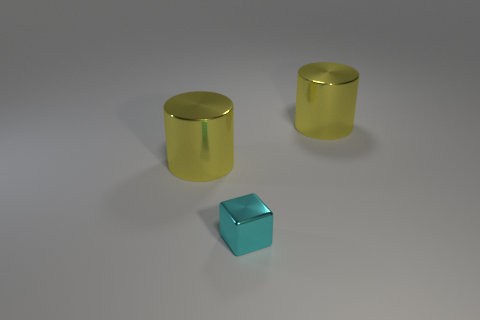Imagine these objects were characters in a story, what personalities might they have? In a realm of imagination, the large cylinders could be portrayed as twin guardians, steadfast and protective with a shimmering golden gleam. The small block may carry the persona of the wise sage, grounded and insightful, with its calming blue presence offering balance and depth to the narrative. 